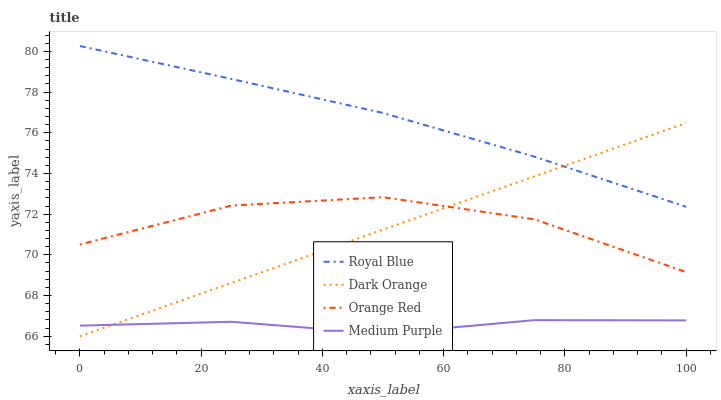Does Medium Purple have the minimum area under the curve?
Answer yes or no. Yes. Does Royal Blue have the maximum area under the curve?
Answer yes or no. Yes. Does Orange Red have the minimum area under the curve?
Answer yes or no. No. Does Orange Red have the maximum area under the curve?
Answer yes or no. No. Is Dark Orange the smoothest?
Answer yes or no. Yes. Is Orange Red the roughest?
Answer yes or no. Yes. Is Royal Blue the smoothest?
Answer yes or no. No. Is Royal Blue the roughest?
Answer yes or no. No. Does Dark Orange have the lowest value?
Answer yes or no. Yes. Does Orange Red have the lowest value?
Answer yes or no. No. Does Royal Blue have the highest value?
Answer yes or no. Yes. Does Orange Red have the highest value?
Answer yes or no. No. Is Medium Purple less than Orange Red?
Answer yes or no. Yes. Is Royal Blue greater than Orange Red?
Answer yes or no. Yes. Does Dark Orange intersect Medium Purple?
Answer yes or no. Yes. Is Dark Orange less than Medium Purple?
Answer yes or no. No. Is Dark Orange greater than Medium Purple?
Answer yes or no. No. Does Medium Purple intersect Orange Red?
Answer yes or no. No. 